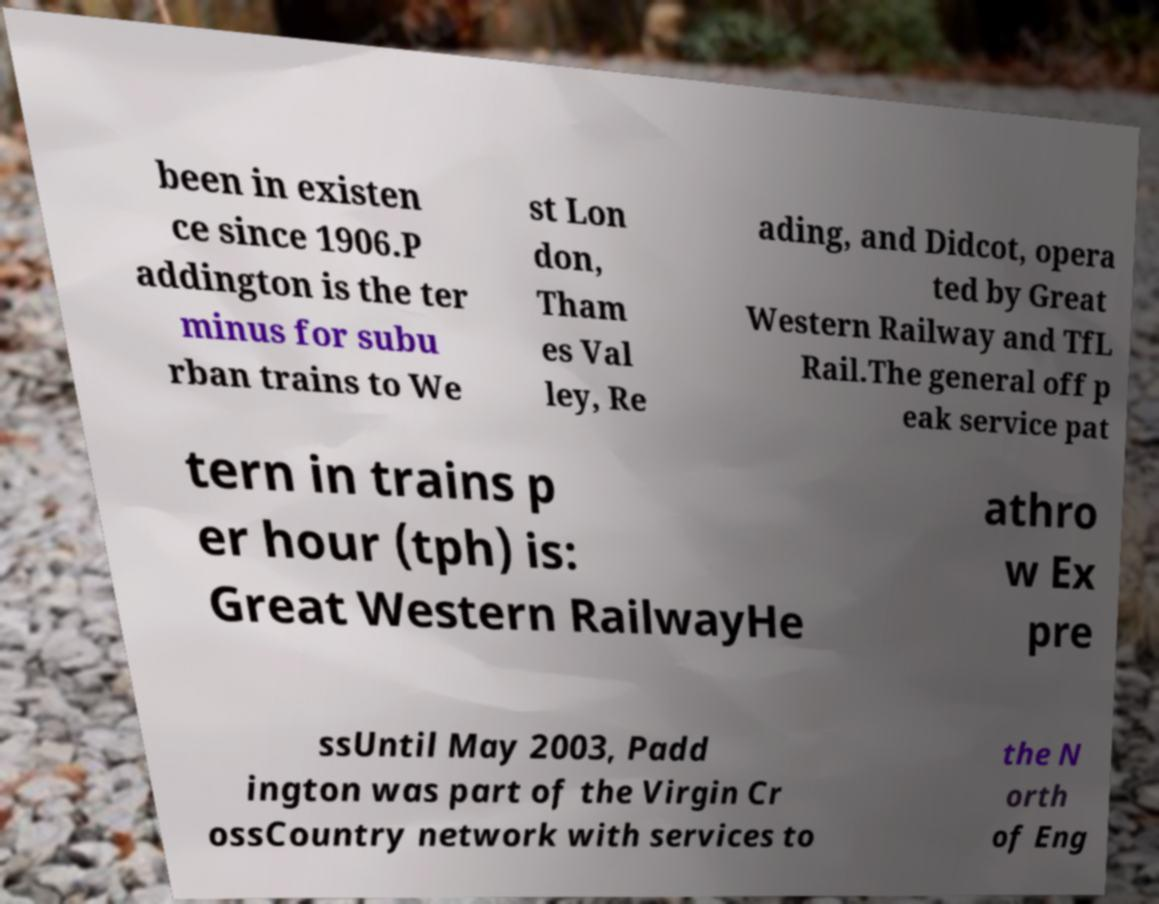There's text embedded in this image that I need extracted. Can you transcribe it verbatim? been in existen ce since 1906.P addington is the ter minus for subu rban trains to We st Lon don, Tham es Val ley, Re ading, and Didcot, opera ted by Great Western Railway and TfL Rail.The general off p eak service pat tern in trains p er hour (tph) is: Great Western RailwayHe athro w Ex pre ssUntil May 2003, Padd ington was part of the Virgin Cr ossCountry network with services to the N orth of Eng 